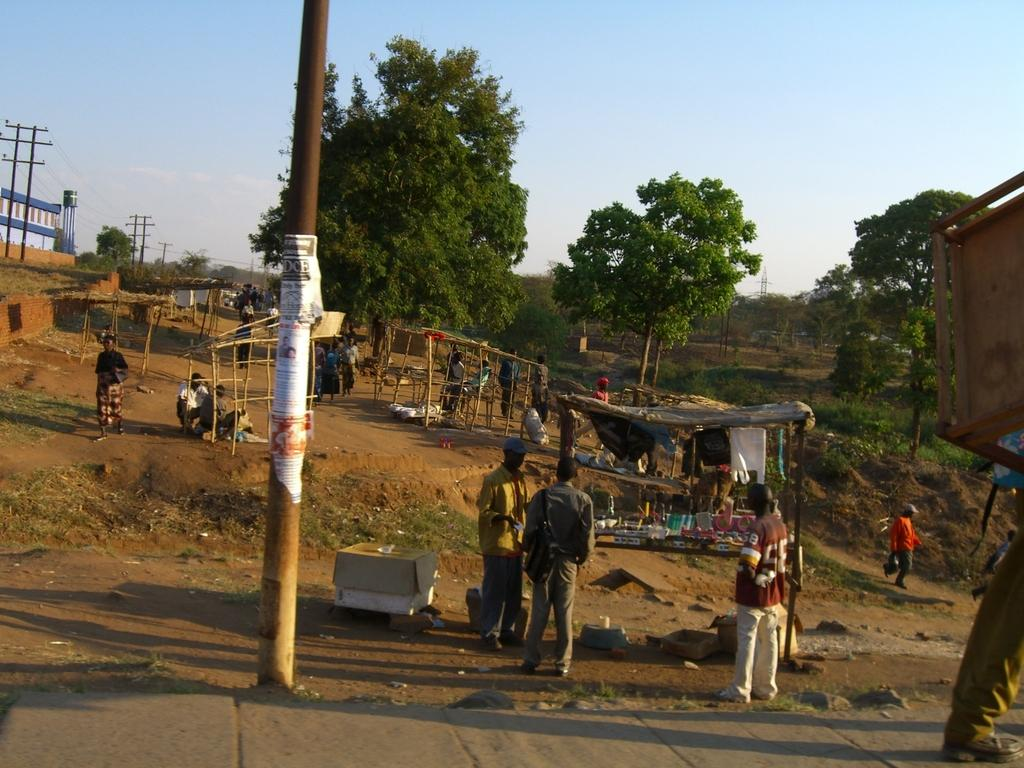How many people are in the image? There are many people in the image. What are the people wearing? The people are wearing clothes. What can be seen in the image besides the people? There is a pole, trees, an electric pole, electric wires, the sky, a sandy area, a wooden tent, and a box in the image. What type of transport can be seen in the image? There is no transport visible in the image. Is there a stranger in the image? The term "stranger" is subjective and cannot be definitively answered based on the provided facts. However, there is no mention of a stranger in the image. 